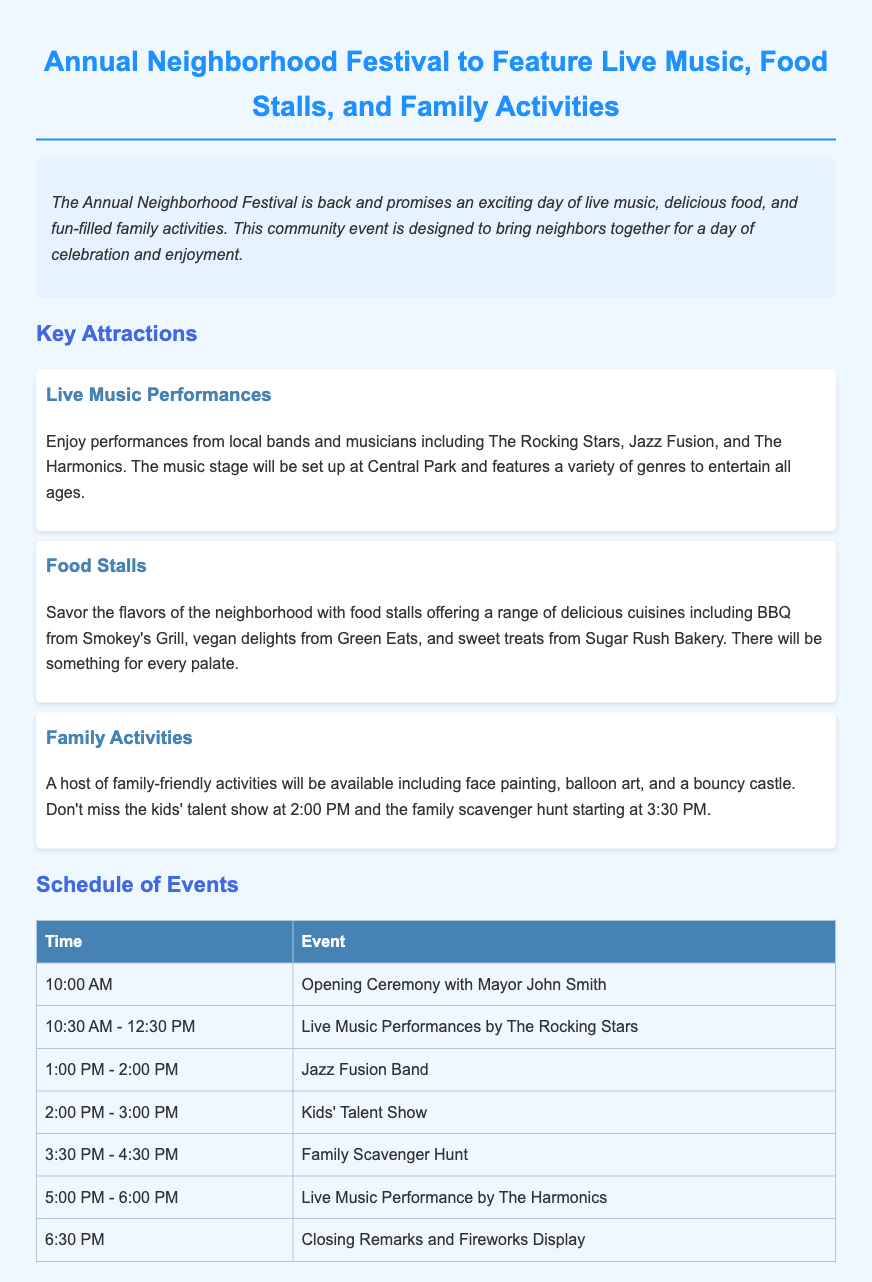What is the name of the festival? The document states that the event is called the Annual Neighborhood Festival.
Answer: Annual Neighborhood Festival What will be featured at the festival? The document highlights that the festival will feature live music, food stalls, and family activities.
Answer: Live music, food stalls, and family activities Who will perform at the festival? According to the document, local bands such as The Rocking Stars, Jazz Fusion, and The Harmonics will perform.
Answer: The Rocking Stars, Jazz Fusion, and The Harmonics What time does the Opening Ceremony start? The schedule in the document indicates that the Opening Ceremony starts at 10:00 AM.
Answer: 10:00 AM What is the event scheduled for 2:00 PM? The document lists the Kids' Talent Show as the event occurring at 2:00 PM.
Answer: Kids' Talent Show Which group performs last during the festival? The schedule mentions that The Harmonics perform last, at 5:00 PM.
Answer: The Harmonics What kind of food can attendees expect? The document specifies various food options, including BBQ from Smokey's Grill and vegan delights from Green Eats.
Answer: BBQ from Smokey's Grill, vegan delights from Green Eats What is one activity for children at the festival? The document highlights face painting as one of the activities available for children.
Answer: Face painting 